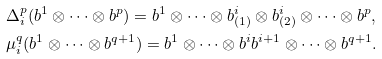Convert formula to latex. <formula><loc_0><loc_0><loc_500><loc_500>& \Delta _ { i } ^ { p } ( b ^ { 1 } \otimes \cdots \otimes b ^ { p } ) = b ^ { 1 } \otimes \cdots \otimes b ^ { i } _ { ( 1 ) } \otimes b ^ { i } _ { ( 2 ) } \otimes \cdots \otimes b ^ { p } , \\ & \mu _ { i } ^ { q } ( b ^ { 1 } \otimes \cdots \otimes b ^ { q + 1 } ) = b ^ { 1 } \otimes \cdots \otimes b ^ { i } b ^ { i + 1 } \otimes \cdots \otimes b ^ { q + 1 } .</formula> 